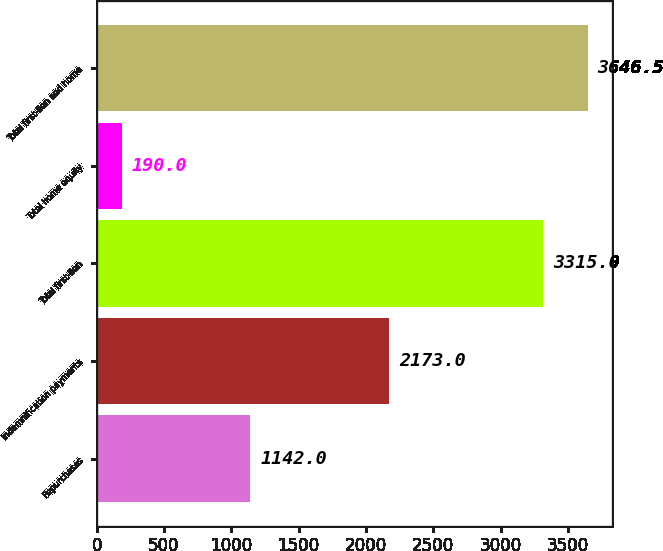Convert chart. <chart><loc_0><loc_0><loc_500><loc_500><bar_chart><fcel>Repurchases<fcel>Indemnification payments<fcel>Total first-lien<fcel>Total home equity<fcel>Total first-lien and home<nl><fcel>1142<fcel>2173<fcel>3315<fcel>190<fcel>3646.5<nl></chart> 